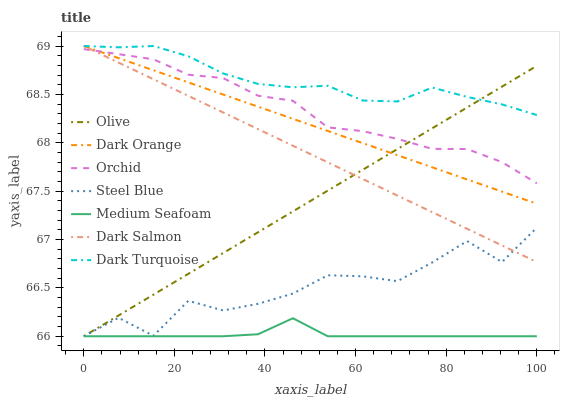Does Medium Seafoam have the minimum area under the curve?
Answer yes or no. Yes. Does Dark Turquoise have the maximum area under the curve?
Answer yes or no. Yes. Does Dark Salmon have the minimum area under the curve?
Answer yes or no. No. Does Dark Salmon have the maximum area under the curve?
Answer yes or no. No. Is Dark Salmon the smoothest?
Answer yes or no. Yes. Is Steel Blue the roughest?
Answer yes or no. Yes. Is Dark Turquoise the smoothest?
Answer yes or no. No. Is Dark Turquoise the roughest?
Answer yes or no. No. Does Steel Blue have the lowest value?
Answer yes or no. Yes. Does Dark Salmon have the lowest value?
Answer yes or no. No. Does Dark Salmon have the highest value?
Answer yes or no. Yes. Does Steel Blue have the highest value?
Answer yes or no. No. Is Medium Seafoam less than Orchid?
Answer yes or no. Yes. Is Dark Turquoise greater than Medium Seafoam?
Answer yes or no. Yes. Does Dark Turquoise intersect Olive?
Answer yes or no. Yes. Is Dark Turquoise less than Olive?
Answer yes or no. No. Is Dark Turquoise greater than Olive?
Answer yes or no. No. Does Medium Seafoam intersect Orchid?
Answer yes or no. No. 